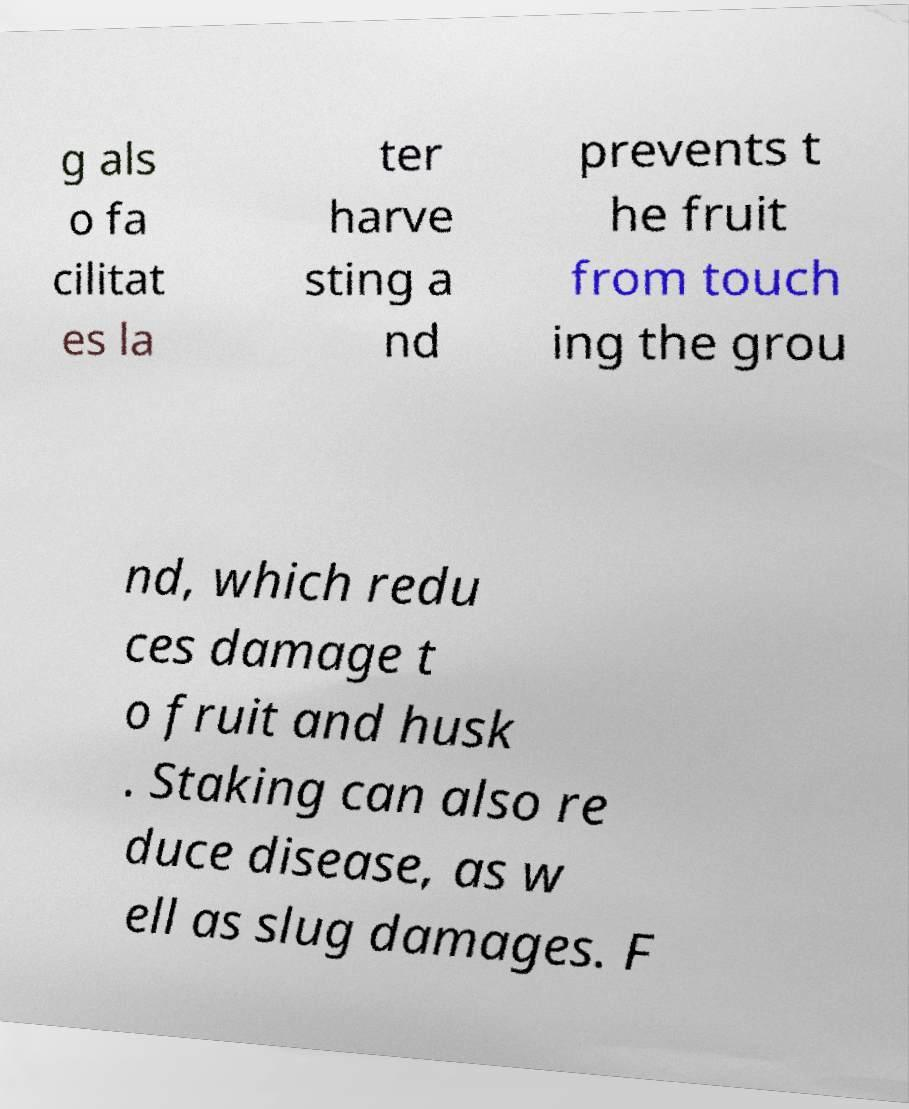I need the written content from this picture converted into text. Can you do that? g als o fa cilitat es la ter harve sting a nd prevents t he fruit from touch ing the grou nd, which redu ces damage t o fruit and husk . Staking can also re duce disease, as w ell as slug damages. F 